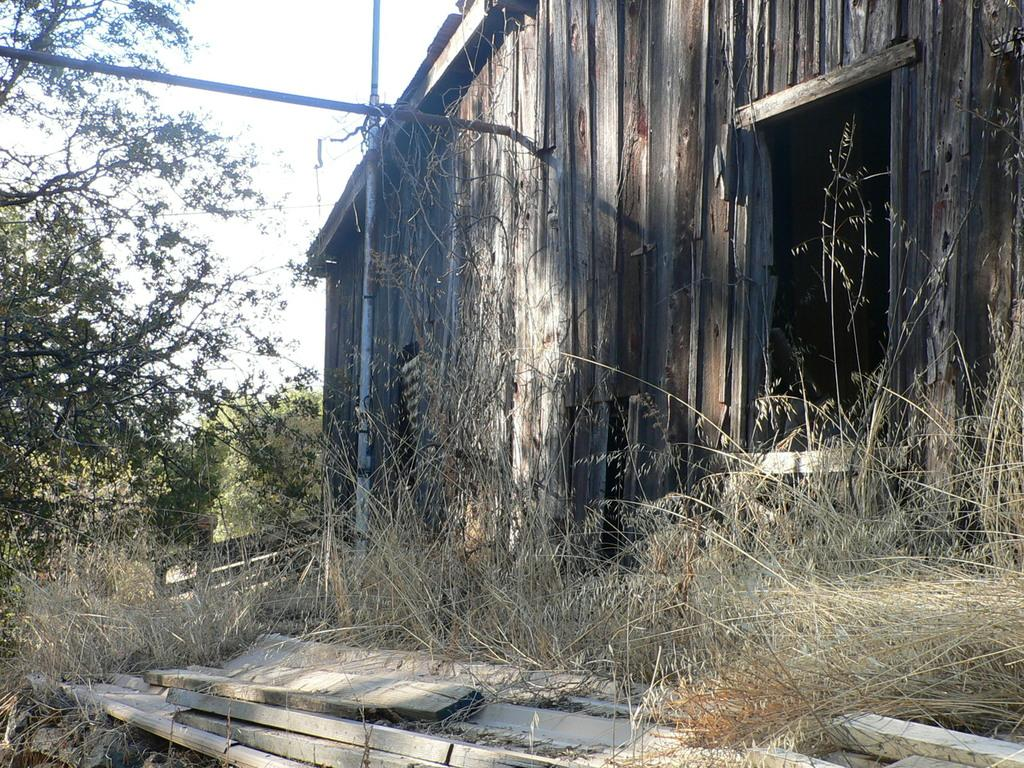What type of vegetation can be seen in the image? There are bushes and trees in the image. What type of structure is present in the image? There is a house in the image. What are the iron poles used for in the image? The iron poles are likely used for supporting or holding something, but their specific purpose is not clear from the image. What is on the ground in the image? There are wooden things on the ground in the image. What can be seen in the background of the image? The sky is visible in the background of the image. What type of table is being used in the competition in the image? There is no table or competition present in the image. What type of pot is being used to cook the food in the image? There is no pot or food being cooked in the image. 